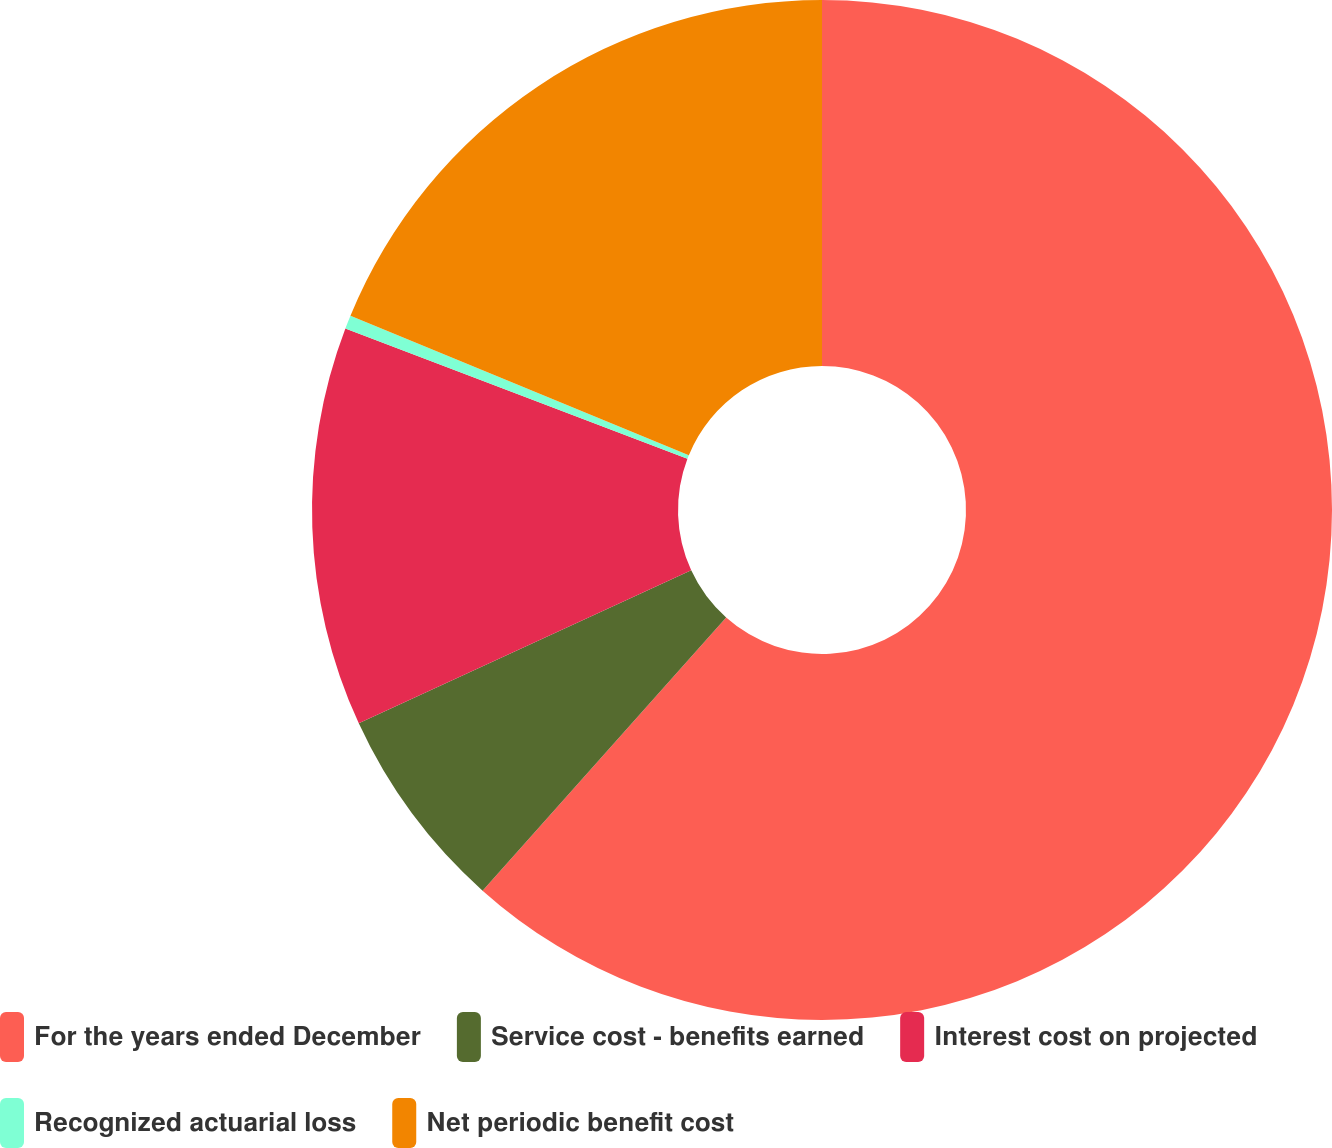Convert chart to OTSL. <chart><loc_0><loc_0><loc_500><loc_500><pie_chart><fcel>For the years ended December<fcel>Service cost - benefits earned<fcel>Interest cost on projected<fcel>Recognized actuarial loss<fcel>Net periodic benefit cost<nl><fcel>61.59%<fcel>6.54%<fcel>12.66%<fcel>0.43%<fcel>18.78%<nl></chart> 